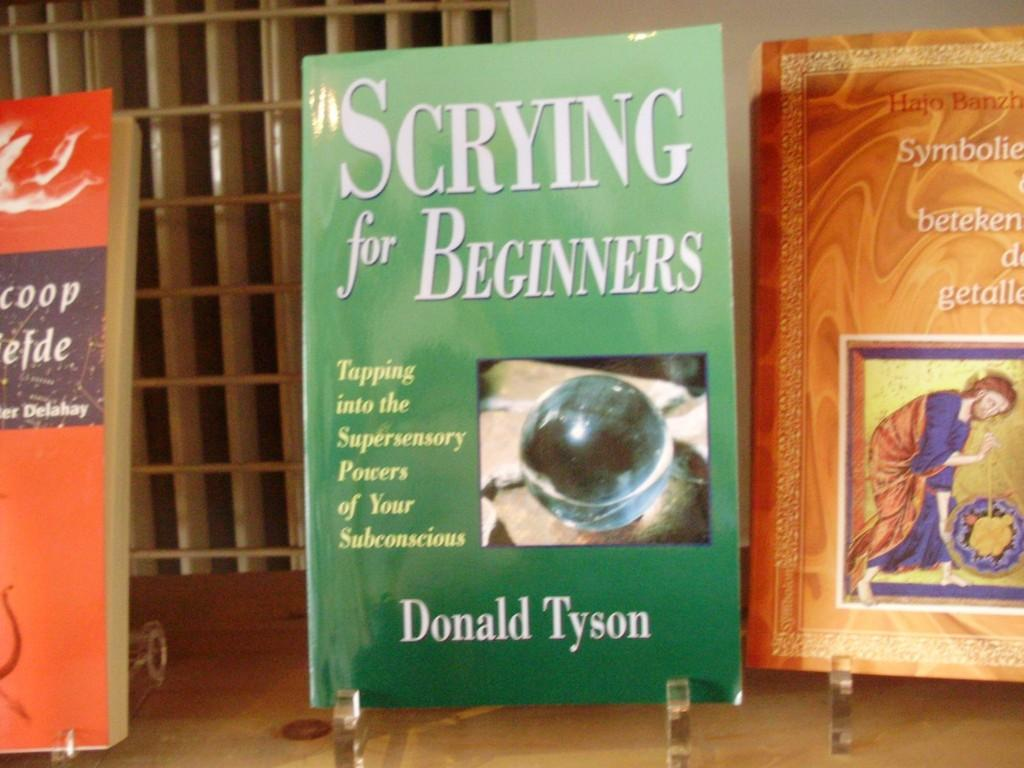Provide a one-sentence caption for the provided image. The books on display included "Scrying for Beginners" by Donald Tyson. 